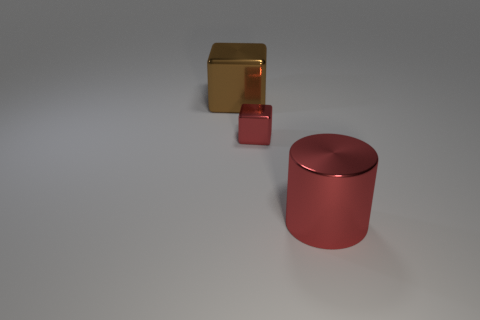Are there any other things that have the same size as the red shiny block?
Keep it short and to the point. No. Are there any metallic blocks that have the same color as the metal cylinder?
Your answer should be compact. Yes. There is a shiny thing that is the same color as the large metal cylinder; what is its size?
Your answer should be very brief. Small. What number of objects are either red shiny objects or metal blocks that are behind the tiny red metal block?
Offer a terse response. 3. There is a red cube that is made of the same material as the large red object; what is its size?
Offer a very short reply. Small. What is the shape of the red metal thing that is in front of the red thing that is behind the large red object?
Ensure brevity in your answer.  Cylinder. What number of gray objects are cylinders or big metallic blocks?
Your response must be concise. 0. Are there any large cylinders behind the tiny red metallic thing on the right side of the large shiny thing that is behind the big cylinder?
Your response must be concise. No. What is the shape of the big object that is the same color as the tiny metallic object?
Offer a terse response. Cylinder. How many tiny things are blue shiny blocks or red cubes?
Make the answer very short. 1. 